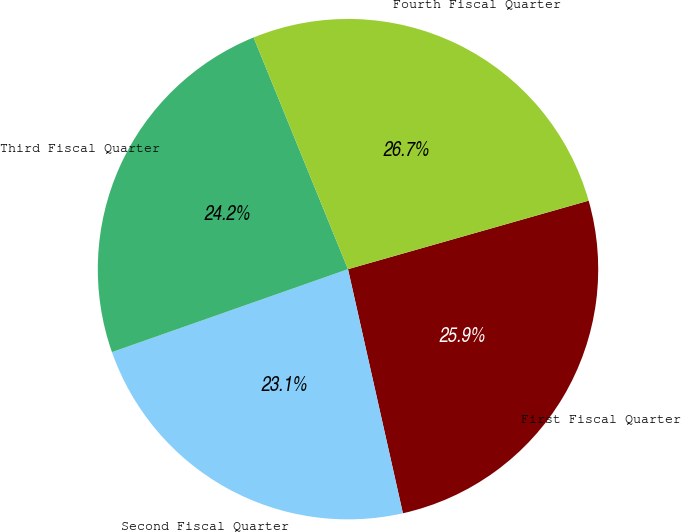Convert chart to OTSL. <chart><loc_0><loc_0><loc_500><loc_500><pie_chart><fcel>First Fiscal Quarter<fcel>Second Fiscal Quarter<fcel>Third Fiscal Quarter<fcel>Fourth Fiscal Quarter<nl><fcel>25.89%<fcel>23.14%<fcel>24.22%<fcel>26.74%<nl></chart> 